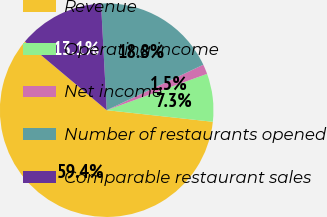<chart> <loc_0><loc_0><loc_500><loc_500><pie_chart><fcel>Revenue<fcel>Operating income<fcel>Net income<fcel>Number of restaurants opened<fcel>Comparable restaurant sales<nl><fcel>59.37%<fcel>7.26%<fcel>1.47%<fcel>18.84%<fcel>13.05%<nl></chart> 